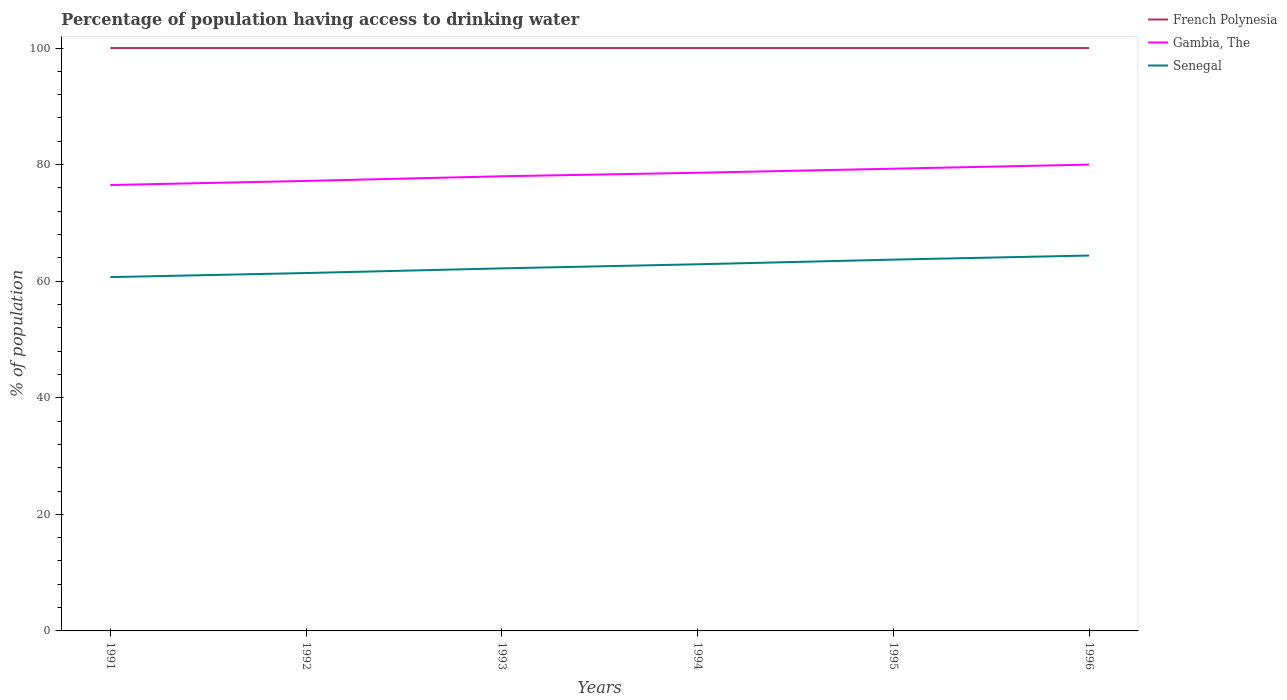Across all years, what is the maximum percentage of population having access to drinking water in Senegal?
Your answer should be very brief. 60.7. What is the total percentage of population having access to drinking water in Gambia, The in the graph?
Make the answer very short. -1.4. What is the difference between the highest and the second highest percentage of population having access to drinking water in French Polynesia?
Ensure brevity in your answer.  0. What is the difference between the highest and the lowest percentage of population having access to drinking water in Senegal?
Your response must be concise. 3. Is the percentage of population having access to drinking water in Gambia, The strictly greater than the percentage of population having access to drinking water in French Polynesia over the years?
Keep it short and to the point. Yes. How many lines are there?
Provide a short and direct response. 3. How many years are there in the graph?
Your answer should be compact. 6. What is the difference between two consecutive major ticks on the Y-axis?
Your answer should be very brief. 20. Are the values on the major ticks of Y-axis written in scientific E-notation?
Your response must be concise. No. Does the graph contain any zero values?
Make the answer very short. No. Does the graph contain grids?
Offer a terse response. No. Where does the legend appear in the graph?
Ensure brevity in your answer.  Top right. What is the title of the graph?
Ensure brevity in your answer.  Percentage of population having access to drinking water. What is the label or title of the X-axis?
Make the answer very short. Years. What is the label or title of the Y-axis?
Your answer should be very brief. % of population. What is the % of population of Gambia, The in 1991?
Your answer should be very brief. 76.5. What is the % of population of Senegal in 1991?
Give a very brief answer. 60.7. What is the % of population in French Polynesia in 1992?
Make the answer very short. 100. What is the % of population in Gambia, The in 1992?
Offer a very short reply. 77.2. What is the % of population in Senegal in 1992?
Offer a terse response. 61.4. What is the % of population of French Polynesia in 1993?
Keep it short and to the point. 100. What is the % of population of Senegal in 1993?
Your answer should be very brief. 62.2. What is the % of population of French Polynesia in 1994?
Provide a succinct answer. 100. What is the % of population of Gambia, The in 1994?
Offer a very short reply. 78.6. What is the % of population of Senegal in 1994?
Provide a succinct answer. 62.9. What is the % of population of French Polynesia in 1995?
Make the answer very short. 100. What is the % of population in Gambia, The in 1995?
Your response must be concise. 79.3. What is the % of population of Senegal in 1995?
Make the answer very short. 63.7. What is the % of population of French Polynesia in 1996?
Keep it short and to the point. 100. What is the % of population in Gambia, The in 1996?
Provide a short and direct response. 80. What is the % of population in Senegal in 1996?
Give a very brief answer. 64.4. Across all years, what is the maximum % of population in Senegal?
Give a very brief answer. 64.4. Across all years, what is the minimum % of population in French Polynesia?
Your response must be concise. 100. Across all years, what is the minimum % of population in Gambia, The?
Give a very brief answer. 76.5. Across all years, what is the minimum % of population in Senegal?
Your answer should be compact. 60.7. What is the total % of population in French Polynesia in the graph?
Provide a short and direct response. 600. What is the total % of population in Gambia, The in the graph?
Offer a terse response. 469.6. What is the total % of population of Senegal in the graph?
Provide a succinct answer. 375.3. What is the difference between the % of population of Senegal in 1991 and that in 1992?
Ensure brevity in your answer.  -0.7. What is the difference between the % of population in French Polynesia in 1991 and that in 1993?
Your response must be concise. 0. What is the difference between the % of population of Gambia, The in 1991 and that in 1993?
Provide a short and direct response. -1.5. What is the difference between the % of population of French Polynesia in 1991 and that in 1995?
Give a very brief answer. 0. What is the difference between the % of population in Gambia, The in 1991 and that in 1996?
Give a very brief answer. -3.5. What is the difference between the % of population of Senegal in 1991 and that in 1996?
Your response must be concise. -3.7. What is the difference between the % of population of French Polynesia in 1992 and that in 1993?
Your response must be concise. 0. What is the difference between the % of population of Gambia, The in 1992 and that in 1993?
Provide a short and direct response. -0.8. What is the difference between the % of population of Gambia, The in 1992 and that in 1994?
Ensure brevity in your answer.  -1.4. What is the difference between the % of population of Senegal in 1992 and that in 1994?
Keep it short and to the point. -1.5. What is the difference between the % of population of French Polynesia in 1992 and that in 1995?
Provide a short and direct response. 0. What is the difference between the % of population in Gambia, The in 1992 and that in 1995?
Your answer should be very brief. -2.1. What is the difference between the % of population in Senegal in 1992 and that in 1995?
Offer a very short reply. -2.3. What is the difference between the % of population in French Polynesia in 1992 and that in 1996?
Make the answer very short. 0. What is the difference between the % of population in Gambia, The in 1992 and that in 1996?
Provide a short and direct response. -2.8. What is the difference between the % of population of French Polynesia in 1993 and that in 1994?
Make the answer very short. 0. What is the difference between the % of population of Gambia, The in 1993 and that in 1994?
Your answer should be compact. -0.6. What is the difference between the % of population in Senegal in 1993 and that in 1994?
Offer a very short reply. -0.7. What is the difference between the % of population in Senegal in 1993 and that in 1995?
Your response must be concise. -1.5. What is the difference between the % of population of French Polynesia in 1993 and that in 1996?
Provide a succinct answer. 0. What is the difference between the % of population of Gambia, The in 1993 and that in 1996?
Your answer should be compact. -2. What is the difference between the % of population in French Polynesia in 1994 and that in 1995?
Provide a succinct answer. 0. What is the difference between the % of population of Senegal in 1994 and that in 1995?
Provide a succinct answer. -0.8. What is the difference between the % of population in French Polynesia in 1994 and that in 1996?
Provide a succinct answer. 0. What is the difference between the % of population of Senegal in 1995 and that in 1996?
Provide a short and direct response. -0.7. What is the difference between the % of population in French Polynesia in 1991 and the % of population in Gambia, The in 1992?
Keep it short and to the point. 22.8. What is the difference between the % of population of French Polynesia in 1991 and the % of population of Senegal in 1992?
Your answer should be compact. 38.6. What is the difference between the % of population in French Polynesia in 1991 and the % of population in Gambia, The in 1993?
Keep it short and to the point. 22. What is the difference between the % of population of French Polynesia in 1991 and the % of population of Senegal in 1993?
Provide a short and direct response. 37.8. What is the difference between the % of population of Gambia, The in 1991 and the % of population of Senegal in 1993?
Provide a short and direct response. 14.3. What is the difference between the % of population in French Polynesia in 1991 and the % of population in Gambia, The in 1994?
Your response must be concise. 21.4. What is the difference between the % of population of French Polynesia in 1991 and the % of population of Senegal in 1994?
Your answer should be very brief. 37.1. What is the difference between the % of population of French Polynesia in 1991 and the % of population of Gambia, The in 1995?
Keep it short and to the point. 20.7. What is the difference between the % of population of French Polynesia in 1991 and the % of population of Senegal in 1995?
Provide a succinct answer. 36.3. What is the difference between the % of population in Gambia, The in 1991 and the % of population in Senegal in 1995?
Make the answer very short. 12.8. What is the difference between the % of population of French Polynesia in 1991 and the % of population of Gambia, The in 1996?
Provide a short and direct response. 20. What is the difference between the % of population in French Polynesia in 1991 and the % of population in Senegal in 1996?
Your response must be concise. 35.6. What is the difference between the % of population of French Polynesia in 1992 and the % of population of Senegal in 1993?
Give a very brief answer. 37.8. What is the difference between the % of population in French Polynesia in 1992 and the % of population in Gambia, The in 1994?
Your answer should be compact. 21.4. What is the difference between the % of population of French Polynesia in 1992 and the % of population of Senegal in 1994?
Ensure brevity in your answer.  37.1. What is the difference between the % of population of Gambia, The in 1992 and the % of population of Senegal in 1994?
Ensure brevity in your answer.  14.3. What is the difference between the % of population in French Polynesia in 1992 and the % of population in Gambia, The in 1995?
Ensure brevity in your answer.  20.7. What is the difference between the % of population of French Polynesia in 1992 and the % of population of Senegal in 1995?
Your response must be concise. 36.3. What is the difference between the % of population in French Polynesia in 1992 and the % of population in Gambia, The in 1996?
Provide a succinct answer. 20. What is the difference between the % of population in French Polynesia in 1992 and the % of population in Senegal in 1996?
Your answer should be very brief. 35.6. What is the difference between the % of population of Gambia, The in 1992 and the % of population of Senegal in 1996?
Give a very brief answer. 12.8. What is the difference between the % of population of French Polynesia in 1993 and the % of population of Gambia, The in 1994?
Keep it short and to the point. 21.4. What is the difference between the % of population of French Polynesia in 1993 and the % of population of Senegal in 1994?
Ensure brevity in your answer.  37.1. What is the difference between the % of population in Gambia, The in 1993 and the % of population in Senegal in 1994?
Provide a short and direct response. 15.1. What is the difference between the % of population of French Polynesia in 1993 and the % of population of Gambia, The in 1995?
Offer a very short reply. 20.7. What is the difference between the % of population of French Polynesia in 1993 and the % of population of Senegal in 1995?
Keep it short and to the point. 36.3. What is the difference between the % of population of Gambia, The in 1993 and the % of population of Senegal in 1995?
Offer a very short reply. 14.3. What is the difference between the % of population in French Polynesia in 1993 and the % of population in Gambia, The in 1996?
Offer a terse response. 20. What is the difference between the % of population in French Polynesia in 1993 and the % of population in Senegal in 1996?
Your answer should be very brief. 35.6. What is the difference between the % of population of French Polynesia in 1994 and the % of population of Gambia, The in 1995?
Offer a very short reply. 20.7. What is the difference between the % of population of French Polynesia in 1994 and the % of population of Senegal in 1995?
Give a very brief answer. 36.3. What is the difference between the % of population in Gambia, The in 1994 and the % of population in Senegal in 1995?
Your answer should be very brief. 14.9. What is the difference between the % of population in French Polynesia in 1994 and the % of population in Senegal in 1996?
Provide a succinct answer. 35.6. What is the difference between the % of population in Gambia, The in 1994 and the % of population in Senegal in 1996?
Provide a succinct answer. 14.2. What is the difference between the % of population of French Polynesia in 1995 and the % of population of Gambia, The in 1996?
Your response must be concise. 20. What is the difference between the % of population in French Polynesia in 1995 and the % of population in Senegal in 1996?
Keep it short and to the point. 35.6. What is the difference between the % of population of Gambia, The in 1995 and the % of population of Senegal in 1996?
Your answer should be compact. 14.9. What is the average % of population of French Polynesia per year?
Your answer should be very brief. 100. What is the average % of population of Gambia, The per year?
Your answer should be compact. 78.27. What is the average % of population in Senegal per year?
Make the answer very short. 62.55. In the year 1991, what is the difference between the % of population of French Polynesia and % of population of Senegal?
Make the answer very short. 39.3. In the year 1991, what is the difference between the % of population of Gambia, The and % of population of Senegal?
Provide a succinct answer. 15.8. In the year 1992, what is the difference between the % of population in French Polynesia and % of population in Gambia, The?
Give a very brief answer. 22.8. In the year 1992, what is the difference between the % of population of French Polynesia and % of population of Senegal?
Provide a succinct answer. 38.6. In the year 1992, what is the difference between the % of population in Gambia, The and % of population in Senegal?
Give a very brief answer. 15.8. In the year 1993, what is the difference between the % of population in French Polynesia and % of population in Gambia, The?
Your response must be concise. 22. In the year 1993, what is the difference between the % of population in French Polynesia and % of population in Senegal?
Provide a succinct answer. 37.8. In the year 1994, what is the difference between the % of population in French Polynesia and % of population in Gambia, The?
Your response must be concise. 21.4. In the year 1994, what is the difference between the % of population of French Polynesia and % of population of Senegal?
Make the answer very short. 37.1. In the year 1995, what is the difference between the % of population of French Polynesia and % of population of Gambia, The?
Keep it short and to the point. 20.7. In the year 1995, what is the difference between the % of population of French Polynesia and % of population of Senegal?
Your response must be concise. 36.3. In the year 1995, what is the difference between the % of population in Gambia, The and % of population in Senegal?
Your answer should be compact. 15.6. In the year 1996, what is the difference between the % of population in French Polynesia and % of population in Gambia, The?
Your response must be concise. 20. In the year 1996, what is the difference between the % of population of French Polynesia and % of population of Senegal?
Your response must be concise. 35.6. What is the ratio of the % of population in Gambia, The in 1991 to that in 1992?
Keep it short and to the point. 0.99. What is the ratio of the % of population of Senegal in 1991 to that in 1992?
Offer a very short reply. 0.99. What is the ratio of the % of population in Gambia, The in 1991 to that in 1993?
Offer a very short reply. 0.98. What is the ratio of the % of population in Senegal in 1991 to that in 1993?
Keep it short and to the point. 0.98. What is the ratio of the % of population in Gambia, The in 1991 to that in 1994?
Offer a terse response. 0.97. What is the ratio of the % of population in Gambia, The in 1991 to that in 1995?
Provide a short and direct response. 0.96. What is the ratio of the % of population in Senegal in 1991 to that in 1995?
Your answer should be compact. 0.95. What is the ratio of the % of population of Gambia, The in 1991 to that in 1996?
Make the answer very short. 0.96. What is the ratio of the % of population of Senegal in 1991 to that in 1996?
Ensure brevity in your answer.  0.94. What is the ratio of the % of population in French Polynesia in 1992 to that in 1993?
Your answer should be compact. 1. What is the ratio of the % of population of Gambia, The in 1992 to that in 1993?
Keep it short and to the point. 0.99. What is the ratio of the % of population of Senegal in 1992 to that in 1993?
Provide a succinct answer. 0.99. What is the ratio of the % of population in Gambia, The in 1992 to that in 1994?
Keep it short and to the point. 0.98. What is the ratio of the % of population in Senegal in 1992 to that in 1994?
Make the answer very short. 0.98. What is the ratio of the % of population in French Polynesia in 1992 to that in 1995?
Provide a succinct answer. 1. What is the ratio of the % of population of Gambia, The in 1992 to that in 1995?
Offer a terse response. 0.97. What is the ratio of the % of population of Senegal in 1992 to that in 1995?
Provide a short and direct response. 0.96. What is the ratio of the % of population in French Polynesia in 1992 to that in 1996?
Your answer should be compact. 1. What is the ratio of the % of population in Gambia, The in 1992 to that in 1996?
Your answer should be compact. 0.96. What is the ratio of the % of population of Senegal in 1992 to that in 1996?
Your answer should be very brief. 0.95. What is the ratio of the % of population in French Polynesia in 1993 to that in 1994?
Make the answer very short. 1. What is the ratio of the % of population in Gambia, The in 1993 to that in 1994?
Your answer should be compact. 0.99. What is the ratio of the % of population in Senegal in 1993 to that in 1994?
Your answer should be very brief. 0.99. What is the ratio of the % of population in Gambia, The in 1993 to that in 1995?
Provide a succinct answer. 0.98. What is the ratio of the % of population in Senegal in 1993 to that in 1995?
Keep it short and to the point. 0.98. What is the ratio of the % of population of French Polynesia in 1993 to that in 1996?
Your answer should be compact. 1. What is the ratio of the % of population of Senegal in 1993 to that in 1996?
Your answer should be compact. 0.97. What is the ratio of the % of population of French Polynesia in 1994 to that in 1995?
Ensure brevity in your answer.  1. What is the ratio of the % of population in Senegal in 1994 to that in 1995?
Keep it short and to the point. 0.99. What is the ratio of the % of population in Gambia, The in 1994 to that in 1996?
Your answer should be very brief. 0.98. What is the ratio of the % of population of Senegal in 1994 to that in 1996?
Give a very brief answer. 0.98. What is the ratio of the % of population in Gambia, The in 1995 to that in 1996?
Your response must be concise. 0.99. What is the difference between the highest and the lowest % of population of French Polynesia?
Your response must be concise. 0. 